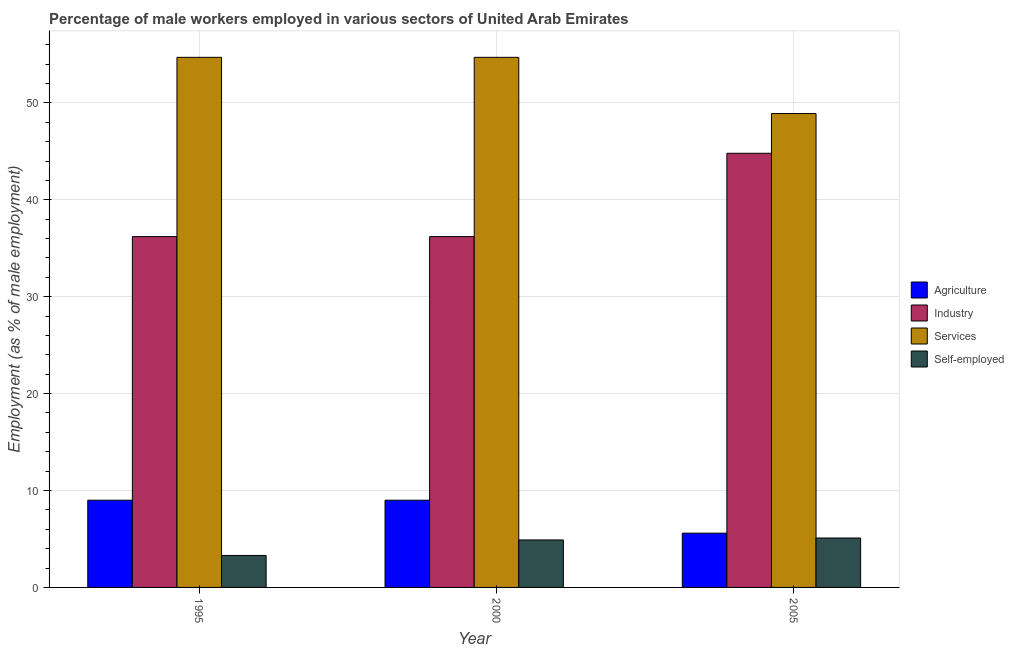How many different coloured bars are there?
Offer a terse response. 4. Are the number of bars on each tick of the X-axis equal?
Your answer should be compact. Yes. In how many cases, is the number of bars for a given year not equal to the number of legend labels?
Your answer should be very brief. 0. What is the percentage of male workers in industry in 2000?
Give a very brief answer. 36.2. Across all years, what is the minimum percentage of male workers in industry?
Your answer should be compact. 36.2. In which year was the percentage of self employed male workers minimum?
Provide a succinct answer. 1995. What is the total percentage of male workers in services in the graph?
Offer a terse response. 158.3. What is the difference between the percentage of self employed male workers in 1995 and that in 2000?
Make the answer very short. -1.6. What is the difference between the percentage of self employed male workers in 1995 and the percentage of male workers in agriculture in 2000?
Make the answer very short. -1.6. What is the average percentage of male workers in services per year?
Provide a short and direct response. 52.77. What is the ratio of the percentage of male workers in industry in 1995 to that in 2005?
Your answer should be very brief. 0.81. Is the percentage of male workers in agriculture in 2000 less than that in 2005?
Keep it short and to the point. No. Is the difference between the percentage of self employed male workers in 1995 and 2005 greater than the difference between the percentage of male workers in agriculture in 1995 and 2005?
Provide a short and direct response. No. What is the difference between the highest and the second highest percentage of self employed male workers?
Provide a short and direct response. 0.2. What is the difference between the highest and the lowest percentage of male workers in agriculture?
Offer a very short reply. 3.4. In how many years, is the percentage of male workers in agriculture greater than the average percentage of male workers in agriculture taken over all years?
Make the answer very short. 2. What does the 3rd bar from the left in 1995 represents?
Keep it short and to the point. Services. What does the 1st bar from the right in 2000 represents?
Ensure brevity in your answer.  Self-employed. Is it the case that in every year, the sum of the percentage of male workers in agriculture and percentage of male workers in industry is greater than the percentage of male workers in services?
Provide a short and direct response. No. How many years are there in the graph?
Provide a succinct answer. 3. What is the difference between two consecutive major ticks on the Y-axis?
Provide a succinct answer. 10. Where does the legend appear in the graph?
Your answer should be very brief. Center right. What is the title of the graph?
Provide a short and direct response. Percentage of male workers employed in various sectors of United Arab Emirates. What is the label or title of the Y-axis?
Provide a short and direct response. Employment (as % of male employment). What is the Employment (as % of male employment) of Industry in 1995?
Provide a succinct answer. 36.2. What is the Employment (as % of male employment) of Services in 1995?
Give a very brief answer. 54.7. What is the Employment (as % of male employment) in Self-employed in 1995?
Keep it short and to the point. 3.3. What is the Employment (as % of male employment) of Agriculture in 2000?
Make the answer very short. 9. What is the Employment (as % of male employment) in Industry in 2000?
Ensure brevity in your answer.  36.2. What is the Employment (as % of male employment) in Services in 2000?
Ensure brevity in your answer.  54.7. What is the Employment (as % of male employment) of Self-employed in 2000?
Your response must be concise. 4.9. What is the Employment (as % of male employment) in Agriculture in 2005?
Provide a short and direct response. 5.6. What is the Employment (as % of male employment) in Industry in 2005?
Your response must be concise. 44.8. What is the Employment (as % of male employment) in Services in 2005?
Make the answer very short. 48.9. What is the Employment (as % of male employment) of Self-employed in 2005?
Keep it short and to the point. 5.1. Across all years, what is the maximum Employment (as % of male employment) of Agriculture?
Give a very brief answer. 9. Across all years, what is the maximum Employment (as % of male employment) of Industry?
Offer a very short reply. 44.8. Across all years, what is the maximum Employment (as % of male employment) of Services?
Provide a short and direct response. 54.7. Across all years, what is the maximum Employment (as % of male employment) in Self-employed?
Your answer should be compact. 5.1. Across all years, what is the minimum Employment (as % of male employment) in Agriculture?
Provide a succinct answer. 5.6. Across all years, what is the minimum Employment (as % of male employment) in Industry?
Keep it short and to the point. 36.2. Across all years, what is the minimum Employment (as % of male employment) of Services?
Provide a succinct answer. 48.9. Across all years, what is the minimum Employment (as % of male employment) in Self-employed?
Give a very brief answer. 3.3. What is the total Employment (as % of male employment) of Agriculture in the graph?
Ensure brevity in your answer.  23.6. What is the total Employment (as % of male employment) in Industry in the graph?
Offer a very short reply. 117.2. What is the total Employment (as % of male employment) of Services in the graph?
Offer a terse response. 158.3. What is the difference between the Employment (as % of male employment) of Industry in 1995 and that in 2000?
Give a very brief answer. 0. What is the difference between the Employment (as % of male employment) in Services in 1995 and that in 2000?
Give a very brief answer. 0. What is the difference between the Employment (as % of male employment) in Self-employed in 1995 and that in 2000?
Your answer should be compact. -1.6. What is the difference between the Employment (as % of male employment) of Agriculture in 1995 and that in 2005?
Offer a terse response. 3.4. What is the difference between the Employment (as % of male employment) in Industry in 1995 and that in 2005?
Make the answer very short. -8.6. What is the difference between the Employment (as % of male employment) in Services in 1995 and that in 2005?
Your answer should be very brief. 5.8. What is the difference between the Employment (as % of male employment) of Self-employed in 1995 and that in 2005?
Provide a succinct answer. -1.8. What is the difference between the Employment (as % of male employment) in Industry in 2000 and that in 2005?
Make the answer very short. -8.6. What is the difference between the Employment (as % of male employment) of Services in 2000 and that in 2005?
Keep it short and to the point. 5.8. What is the difference between the Employment (as % of male employment) of Agriculture in 1995 and the Employment (as % of male employment) of Industry in 2000?
Offer a very short reply. -27.2. What is the difference between the Employment (as % of male employment) in Agriculture in 1995 and the Employment (as % of male employment) in Services in 2000?
Provide a short and direct response. -45.7. What is the difference between the Employment (as % of male employment) of Agriculture in 1995 and the Employment (as % of male employment) of Self-employed in 2000?
Your answer should be very brief. 4.1. What is the difference between the Employment (as % of male employment) of Industry in 1995 and the Employment (as % of male employment) of Services in 2000?
Offer a very short reply. -18.5. What is the difference between the Employment (as % of male employment) of Industry in 1995 and the Employment (as % of male employment) of Self-employed in 2000?
Give a very brief answer. 31.3. What is the difference between the Employment (as % of male employment) of Services in 1995 and the Employment (as % of male employment) of Self-employed in 2000?
Offer a terse response. 49.8. What is the difference between the Employment (as % of male employment) of Agriculture in 1995 and the Employment (as % of male employment) of Industry in 2005?
Make the answer very short. -35.8. What is the difference between the Employment (as % of male employment) of Agriculture in 1995 and the Employment (as % of male employment) of Services in 2005?
Make the answer very short. -39.9. What is the difference between the Employment (as % of male employment) in Industry in 1995 and the Employment (as % of male employment) in Services in 2005?
Give a very brief answer. -12.7. What is the difference between the Employment (as % of male employment) in Industry in 1995 and the Employment (as % of male employment) in Self-employed in 2005?
Offer a very short reply. 31.1. What is the difference between the Employment (as % of male employment) in Services in 1995 and the Employment (as % of male employment) in Self-employed in 2005?
Your answer should be very brief. 49.6. What is the difference between the Employment (as % of male employment) of Agriculture in 2000 and the Employment (as % of male employment) of Industry in 2005?
Your answer should be compact. -35.8. What is the difference between the Employment (as % of male employment) of Agriculture in 2000 and the Employment (as % of male employment) of Services in 2005?
Your answer should be very brief. -39.9. What is the difference between the Employment (as % of male employment) of Agriculture in 2000 and the Employment (as % of male employment) of Self-employed in 2005?
Your answer should be very brief. 3.9. What is the difference between the Employment (as % of male employment) of Industry in 2000 and the Employment (as % of male employment) of Self-employed in 2005?
Offer a terse response. 31.1. What is the difference between the Employment (as % of male employment) in Services in 2000 and the Employment (as % of male employment) in Self-employed in 2005?
Provide a succinct answer. 49.6. What is the average Employment (as % of male employment) of Agriculture per year?
Provide a short and direct response. 7.87. What is the average Employment (as % of male employment) in Industry per year?
Ensure brevity in your answer.  39.07. What is the average Employment (as % of male employment) in Services per year?
Offer a terse response. 52.77. What is the average Employment (as % of male employment) in Self-employed per year?
Offer a very short reply. 4.43. In the year 1995, what is the difference between the Employment (as % of male employment) in Agriculture and Employment (as % of male employment) in Industry?
Provide a short and direct response. -27.2. In the year 1995, what is the difference between the Employment (as % of male employment) of Agriculture and Employment (as % of male employment) of Services?
Your response must be concise. -45.7. In the year 1995, what is the difference between the Employment (as % of male employment) of Agriculture and Employment (as % of male employment) of Self-employed?
Keep it short and to the point. 5.7. In the year 1995, what is the difference between the Employment (as % of male employment) in Industry and Employment (as % of male employment) in Services?
Make the answer very short. -18.5. In the year 1995, what is the difference between the Employment (as % of male employment) in Industry and Employment (as % of male employment) in Self-employed?
Your answer should be very brief. 32.9. In the year 1995, what is the difference between the Employment (as % of male employment) of Services and Employment (as % of male employment) of Self-employed?
Your answer should be compact. 51.4. In the year 2000, what is the difference between the Employment (as % of male employment) in Agriculture and Employment (as % of male employment) in Industry?
Ensure brevity in your answer.  -27.2. In the year 2000, what is the difference between the Employment (as % of male employment) of Agriculture and Employment (as % of male employment) of Services?
Provide a succinct answer. -45.7. In the year 2000, what is the difference between the Employment (as % of male employment) of Industry and Employment (as % of male employment) of Services?
Provide a succinct answer. -18.5. In the year 2000, what is the difference between the Employment (as % of male employment) of Industry and Employment (as % of male employment) of Self-employed?
Make the answer very short. 31.3. In the year 2000, what is the difference between the Employment (as % of male employment) of Services and Employment (as % of male employment) of Self-employed?
Give a very brief answer. 49.8. In the year 2005, what is the difference between the Employment (as % of male employment) of Agriculture and Employment (as % of male employment) of Industry?
Offer a terse response. -39.2. In the year 2005, what is the difference between the Employment (as % of male employment) in Agriculture and Employment (as % of male employment) in Services?
Give a very brief answer. -43.3. In the year 2005, what is the difference between the Employment (as % of male employment) in Agriculture and Employment (as % of male employment) in Self-employed?
Offer a terse response. 0.5. In the year 2005, what is the difference between the Employment (as % of male employment) of Industry and Employment (as % of male employment) of Services?
Provide a succinct answer. -4.1. In the year 2005, what is the difference between the Employment (as % of male employment) in Industry and Employment (as % of male employment) in Self-employed?
Keep it short and to the point. 39.7. In the year 2005, what is the difference between the Employment (as % of male employment) in Services and Employment (as % of male employment) in Self-employed?
Offer a terse response. 43.8. What is the ratio of the Employment (as % of male employment) in Services in 1995 to that in 2000?
Ensure brevity in your answer.  1. What is the ratio of the Employment (as % of male employment) in Self-employed in 1995 to that in 2000?
Your response must be concise. 0.67. What is the ratio of the Employment (as % of male employment) of Agriculture in 1995 to that in 2005?
Your answer should be very brief. 1.61. What is the ratio of the Employment (as % of male employment) in Industry in 1995 to that in 2005?
Your response must be concise. 0.81. What is the ratio of the Employment (as % of male employment) in Services in 1995 to that in 2005?
Ensure brevity in your answer.  1.12. What is the ratio of the Employment (as % of male employment) of Self-employed in 1995 to that in 2005?
Your response must be concise. 0.65. What is the ratio of the Employment (as % of male employment) of Agriculture in 2000 to that in 2005?
Make the answer very short. 1.61. What is the ratio of the Employment (as % of male employment) in Industry in 2000 to that in 2005?
Provide a short and direct response. 0.81. What is the ratio of the Employment (as % of male employment) in Services in 2000 to that in 2005?
Your answer should be compact. 1.12. What is the ratio of the Employment (as % of male employment) in Self-employed in 2000 to that in 2005?
Make the answer very short. 0.96. What is the difference between the highest and the second highest Employment (as % of male employment) of Agriculture?
Offer a very short reply. 0. What is the difference between the highest and the second highest Employment (as % of male employment) in Industry?
Provide a short and direct response. 8.6. What is the difference between the highest and the lowest Employment (as % of male employment) in Industry?
Provide a succinct answer. 8.6. What is the difference between the highest and the lowest Employment (as % of male employment) in Services?
Give a very brief answer. 5.8. What is the difference between the highest and the lowest Employment (as % of male employment) of Self-employed?
Provide a succinct answer. 1.8. 